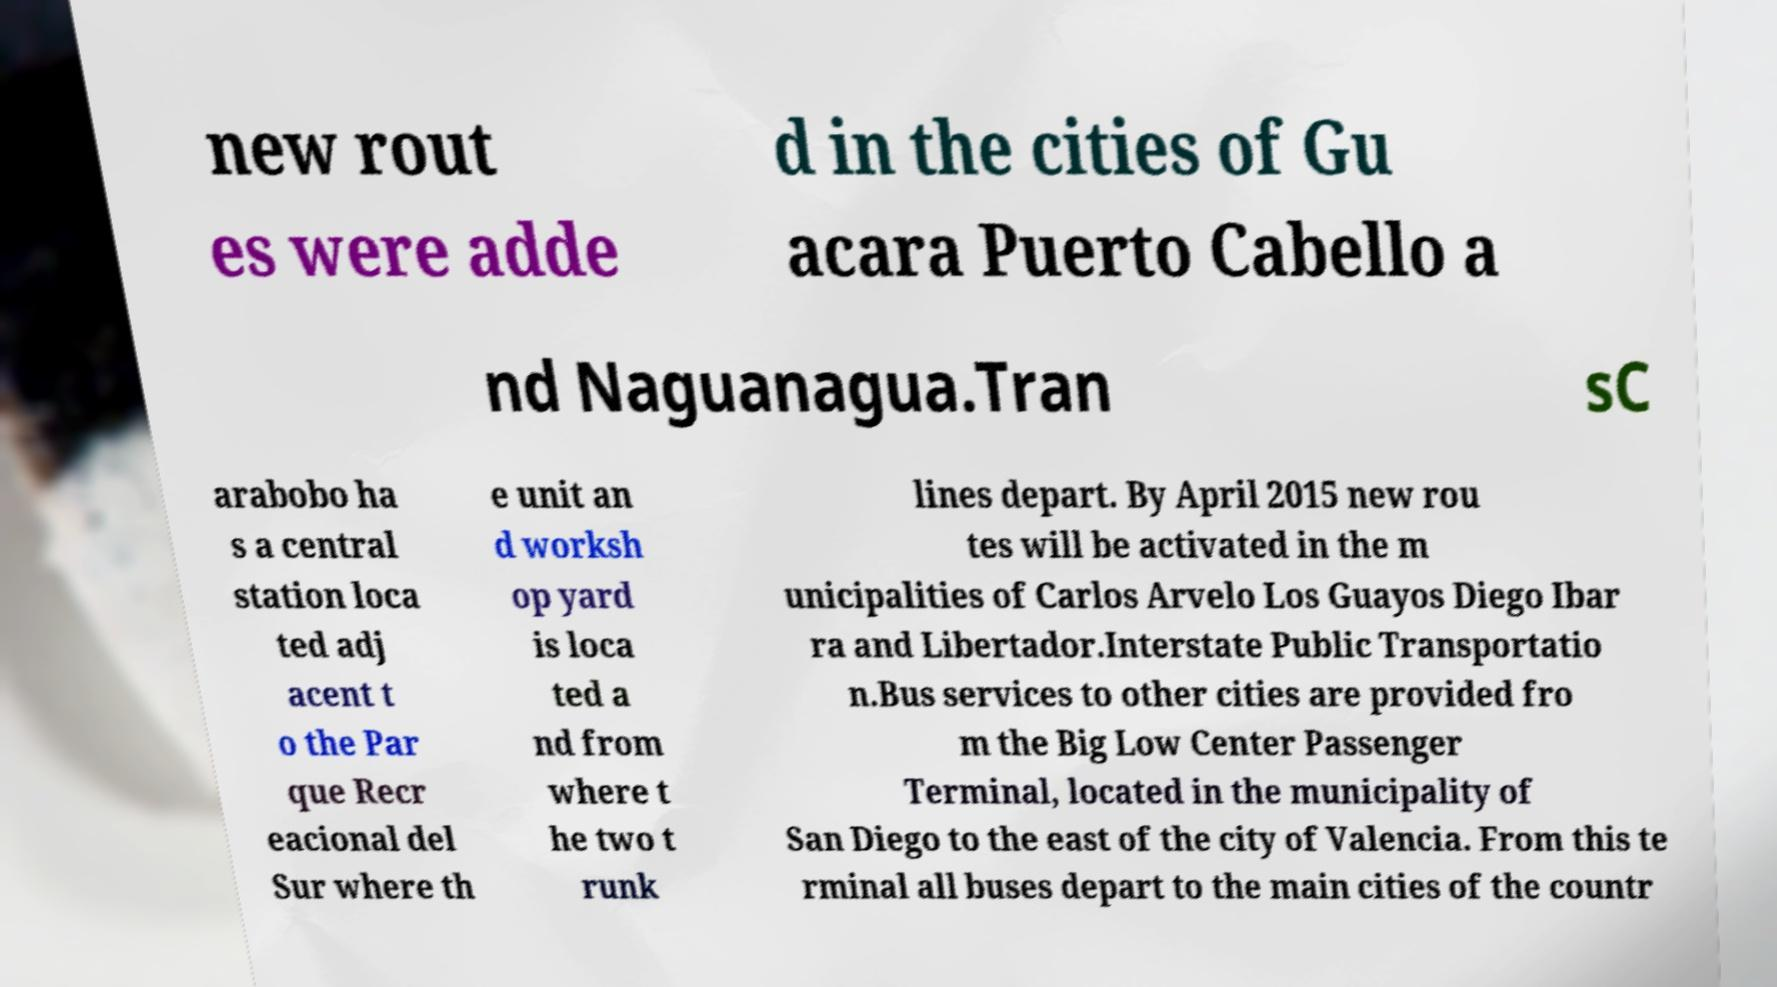I need the written content from this picture converted into text. Can you do that? new rout es were adde d in the cities of Gu acara Puerto Cabello a nd Naguanagua.Tran sC arabobo ha s a central station loca ted adj acent t o the Par que Recr eacional del Sur where th e unit an d worksh op yard is loca ted a nd from where t he two t runk lines depart. By April 2015 new rou tes will be activated in the m unicipalities of Carlos Arvelo Los Guayos Diego Ibar ra and Libertador.Interstate Public Transportatio n.Bus services to other cities are provided fro m the Big Low Center Passenger Terminal, located in the municipality of San Diego to the east of the city of Valencia. From this te rminal all buses depart to the main cities of the countr 